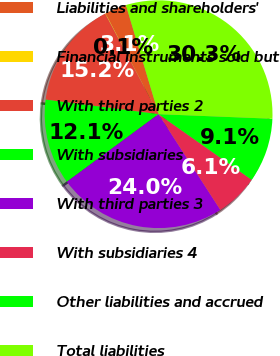Convert chart. <chart><loc_0><loc_0><loc_500><loc_500><pie_chart><fcel>Liabilities and shareholders'<fcel>Financial instruments sold but<fcel>With third parties 2<fcel>With subsidiaries<fcel>With third parties 3<fcel>With subsidiaries 4<fcel>Other liabilities and accrued<fcel>Total liabilities<nl><fcel>3.09%<fcel>0.07%<fcel>15.17%<fcel>12.15%<fcel>24.02%<fcel>6.11%<fcel>9.13%<fcel>30.28%<nl></chart> 